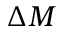Convert formula to latex. <formula><loc_0><loc_0><loc_500><loc_500>\Delta M</formula> 